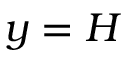<formula> <loc_0><loc_0><loc_500><loc_500>y = H</formula> 